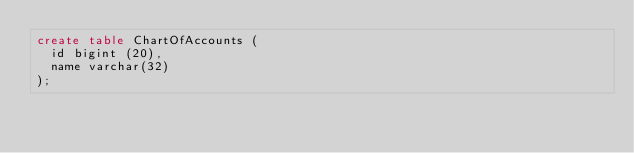Convert code to text. <code><loc_0><loc_0><loc_500><loc_500><_SQL_>create table ChartOfAccounts (
  id bigint (20),
  name varchar(32)
);</code> 